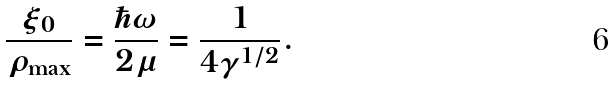<formula> <loc_0><loc_0><loc_500><loc_500>\frac { \xi _ { 0 } } { \rho _ { \mathrm \max } } = \frac { \hbar { \omega } } { 2 \mu } = \frac { 1 } { 4 \gamma ^ { 1 / 2 } } .</formula> 